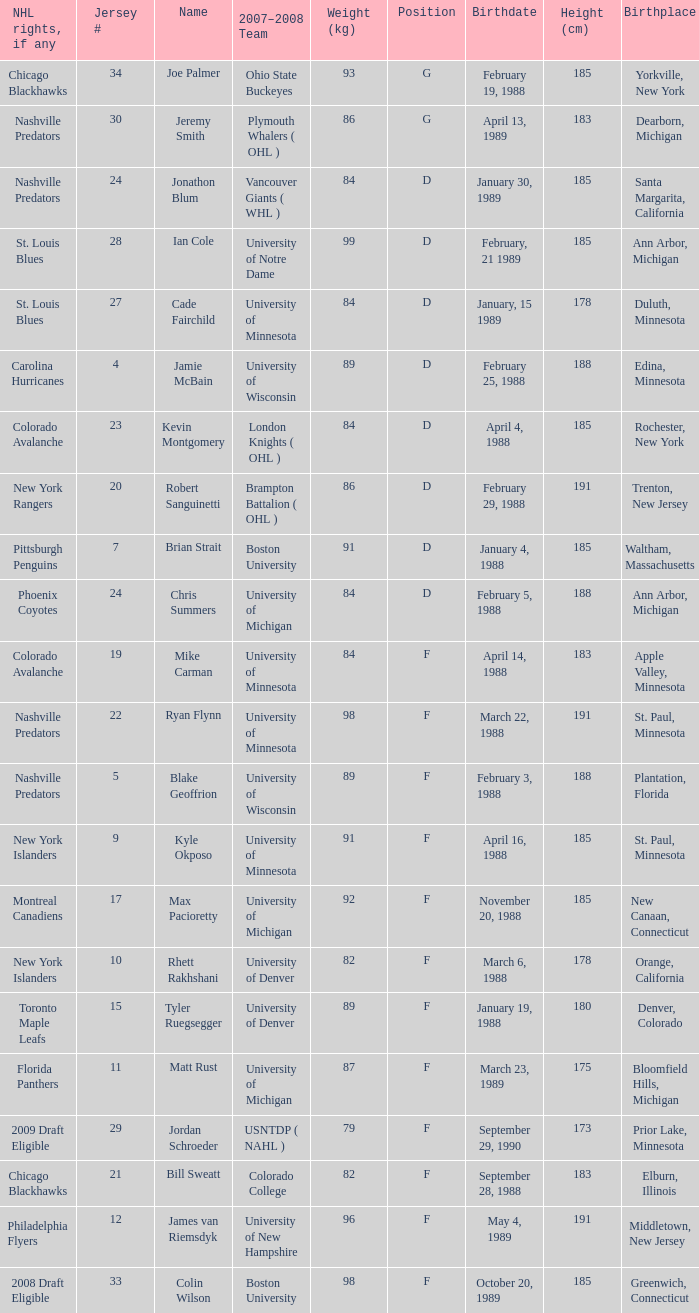What is the height in centimeters of someone born in new canaan, connecticut? 1.0. 